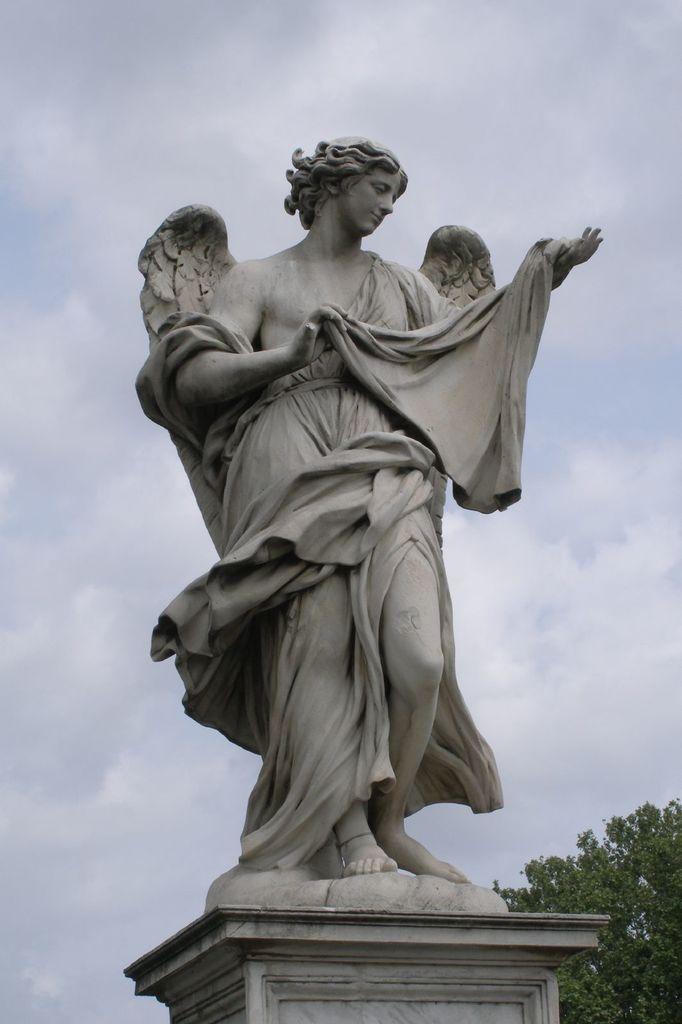In one or two sentences, can you explain what this image depicts? In this picture we can observe a statue of a woman. This statue is in grey color. In the background we can observe a tree and a sky with some clouds. 